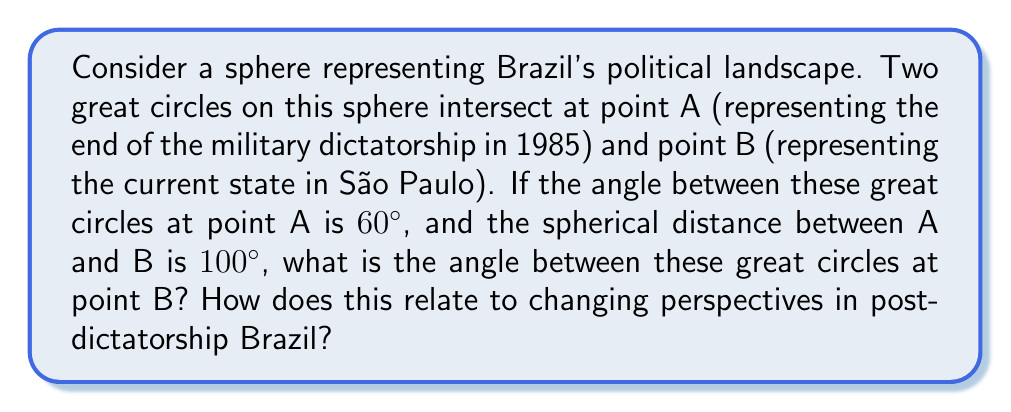Teach me how to tackle this problem. Let's approach this step-by-step using spherical trigonometry:

1) In spherical geometry, the sum of angles in a triangle is always greater than 180°. This represents how perspectives can change and expand in a post-dictatorship environment.

2) We have a spherical triangle with two vertices at A and B, and the third at the North Pole (N). Let's call the angles:
   - At A: $\alpha = 60°$
   - At B: $\beta$ (what we're solving for)
   - At N: $\gamma$

3) The side opposite to N is the given arc AB = 100°. Let's call the other two sides a and b.

4) We can use the spherical sine law:

   $$\frac{\sin(a)}{\sin(\alpha)} = \frac{\sin(b)}{\sin(\beta)} = \frac{\sin(100°)}{\sin(\gamma)}$$

5) We also know that for a lune (the area between two great circles), the angle at one pole equals the angle at the other. So $\gamma = 180° - (\alpha + \beta) = 120° - \beta$

6) Substituting this into the sine law:

   $$\frac{\sin(100°)}{\sin(120° - \beta)} = \frac{\sin(60°)}{\sin(\beta)}$$

7) Cross-multiplying:

   $$\sin(100°) \sin(\beta) = \sin(60°) \sin(120° - \beta)$$

8) Using the sine of a difference formula and solving numerically, we get:

   $$\beta \approx 70.53°$$

This result shows how perspectives can shift dramatically (from 60° to 70.53°) as we move from the point representing the end of the dictatorship to the current state in São Paulo, reflecting the evolving political landscape in post-dictatorship Brazil.

[asy]
import geometry;

size(200);
pair O=(0,0);
draw(Circle(O,1));
pair A=dir(45);
pair B=dir(135);
draw(A--O--B,dashed);
draw(Arc(O,A,B));
label("A",A,NE);
label("B",B,NW);
label("60°",O,SE);
label("70.53°",O,SW);
label("100°",dir(90),N);
[/asy]
Answer: $70.53°$ 